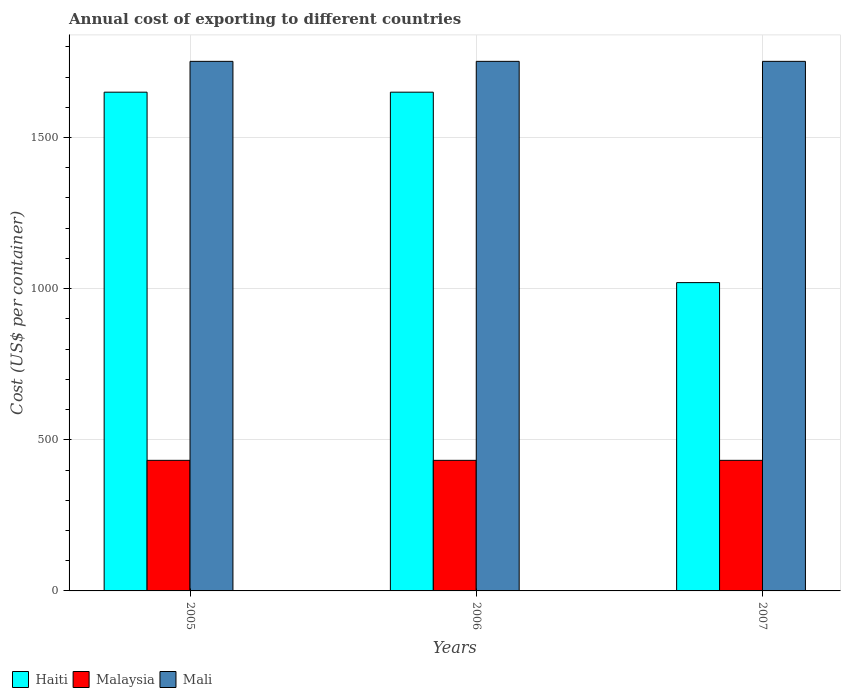Are the number of bars per tick equal to the number of legend labels?
Give a very brief answer. Yes. Are the number of bars on each tick of the X-axis equal?
Offer a very short reply. Yes. How many bars are there on the 1st tick from the left?
Make the answer very short. 3. In how many cases, is the number of bars for a given year not equal to the number of legend labels?
Make the answer very short. 0. What is the total annual cost of exporting in Mali in 2005?
Offer a terse response. 1752. Across all years, what is the maximum total annual cost of exporting in Haiti?
Offer a terse response. 1650. Across all years, what is the minimum total annual cost of exporting in Malaysia?
Provide a short and direct response. 432. What is the total total annual cost of exporting in Haiti in the graph?
Give a very brief answer. 4320. What is the difference between the total annual cost of exporting in Malaysia in 2005 and that in 2006?
Offer a terse response. 0. What is the difference between the total annual cost of exporting in Mali in 2005 and the total annual cost of exporting in Haiti in 2006?
Provide a short and direct response. 102. What is the average total annual cost of exporting in Mali per year?
Make the answer very short. 1752. In the year 2007, what is the difference between the total annual cost of exporting in Haiti and total annual cost of exporting in Malaysia?
Your answer should be very brief. 588. Is the total annual cost of exporting in Mali in 2005 less than that in 2007?
Offer a very short reply. No. What is the difference between the highest and the lowest total annual cost of exporting in Haiti?
Your response must be concise. 630. Is the sum of the total annual cost of exporting in Mali in 2005 and 2007 greater than the maximum total annual cost of exporting in Haiti across all years?
Give a very brief answer. Yes. What does the 2nd bar from the left in 2006 represents?
Offer a very short reply. Malaysia. What does the 1st bar from the right in 2006 represents?
Ensure brevity in your answer.  Mali. Are all the bars in the graph horizontal?
Keep it short and to the point. No. How many years are there in the graph?
Make the answer very short. 3. How many legend labels are there?
Give a very brief answer. 3. How are the legend labels stacked?
Give a very brief answer. Horizontal. What is the title of the graph?
Keep it short and to the point. Annual cost of exporting to different countries. What is the label or title of the Y-axis?
Offer a very short reply. Cost (US$ per container). What is the Cost (US$ per container) of Haiti in 2005?
Make the answer very short. 1650. What is the Cost (US$ per container) in Malaysia in 2005?
Provide a short and direct response. 432. What is the Cost (US$ per container) of Mali in 2005?
Offer a terse response. 1752. What is the Cost (US$ per container) of Haiti in 2006?
Your answer should be very brief. 1650. What is the Cost (US$ per container) in Malaysia in 2006?
Your answer should be compact. 432. What is the Cost (US$ per container) in Mali in 2006?
Your answer should be very brief. 1752. What is the Cost (US$ per container) in Haiti in 2007?
Make the answer very short. 1020. What is the Cost (US$ per container) in Malaysia in 2007?
Give a very brief answer. 432. What is the Cost (US$ per container) in Mali in 2007?
Your answer should be very brief. 1752. Across all years, what is the maximum Cost (US$ per container) of Haiti?
Give a very brief answer. 1650. Across all years, what is the maximum Cost (US$ per container) of Malaysia?
Your answer should be compact. 432. Across all years, what is the maximum Cost (US$ per container) in Mali?
Ensure brevity in your answer.  1752. Across all years, what is the minimum Cost (US$ per container) in Haiti?
Offer a terse response. 1020. Across all years, what is the minimum Cost (US$ per container) in Malaysia?
Your answer should be very brief. 432. Across all years, what is the minimum Cost (US$ per container) in Mali?
Give a very brief answer. 1752. What is the total Cost (US$ per container) in Haiti in the graph?
Keep it short and to the point. 4320. What is the total Cost (US$ per container) of Malaysia in the graph?
Keep it short and to the point. 1296. What is the total Cost (US$ per container) of Mali in the graph?
Give a very brief answer. 5256. What is the difference between the Cost (US$ per container) of Haiti in 2005 and that in 2006?
Ensure brevity in your answer.  0. What is the difference between the Cost (US$ per container) in Haiti in 2005 and that in 2007?
Give a very brief answer. 630. What is the difference between the Cost (US$ per container) in Malaysia in 2005 and that in 2007?
Your response must be concise. 0. What is the difference between the Cost (US$ per container) in Haiti in 2006 and that in 2007?
Make the answer very short. 630. What is the difference between the Cost (US$ per container) of Malaysia in 2006 and that in 2007?
Give a very brief answer. 0. What is the difference between the Cost (US$ per container) of Haiti in 2005 and the Cost (US$ per container) of Malaysia in 2006?
Your answer should be very brief. 1218. What is the difference between the Cost (US$ per container) in Haiti in 2005 and the Cost (US$ per container) in Mali in 2006?
Offer a terse response. -102. What is the difference between the Cost (US$ per container) of Malaysia in 2005 and the Cost (US$ per container) of Mali in 2006?
Offer a very short reply. -1320. What is the difference between the Cost (US$ per container) in Haiti in 2005 and the Cost (US$ per container) in Malaysia in 2007?
Your answer should be compact. 1218. What is the difference between the Cost (US$ per container) of Haiti in 2005 and the Cost (US$ per container) of Mali in 2007?
Ensure brevity in your answer.  -102. What is the difference between the Cost (US$ per container) in Malaysia in 2005 and the Cost (US$ per container) in Mali in 2007?
Ensure brevity in your answer.  -1320. What is the difference between the Cost (US$ per container) of Haiti in 2006 and the Cost (US$ per container) of Malaysia in 2007?
Provide a succinct answer. 1218. What is the difference between the Cost (US$ per container) of Haiti in 2006 and the Cost (US$ per container) of Mali in 2007?
Keep it short and to the point. -102. What is the difference between the Cost (US$ per container) in Malaysia in 2006 and the Cost (US$ per container) in Mali in 2007?
Your answer should be very brief. -1320. What is the average Cost (US$ per container) in Haiti per year?
Ensure brevity in your answer.  1440. What is the average Cost (US$ per container) in Malaysia per year?
Your answer should be very brief. 432. What is the average Cost (US$ per container) of Mali per year?
Provide a succinct answer. 1752. In the year 2005, what is the difference between the Cost (US$ per container) of Haiti and Cost (US$ per container) of Malaysia?
Provide a succinct answer. 1218. In the year 2005, what is the difference between the Cost (US$ per container) of Haiti and Cost (US$ per container) of Mali?
Ensure brevity in your answer.  -102. In the year 2005, what is the difference between the Cost (US$ per container) in Malaysia and Cost (US$ per container) in Mali?
Keep it short and to the point. -1320. In the year 2006, what is the difference between the Cost (US$ per container) of Haiti and Cost (US$ per container) of Malaysia?
Your response must be concise. 1218. In the year 2006, what is the difference between the Cost (US$ per container) of Haiti and Cost (US$ per container) of Mali?
Offer a very short reply. -102. In the year 2006, what is the difference between the Cost (US$ per container) of Malaysia and Cost (US$ per container) of Mali?
Offer a very short reply. -1320. In the year 2007, what is the difference between the Cost (US$ per container) in Haiti and Cost (US$ per container) in Malaysia?
Ensure brevity in your answer.  588. In the year 2007, what is the difference between the Cost (US$ per container) of Haiti and Cost (US$ per container) of Mali?
Offer a terse response. -732. In the year 2007, what is the difference between the Cost (US$ per container) of Malaysia and Cost (US$ per container) of Mali?
Offer a terse response. -1320. What is the ratio of the Cost (US$ per container) in Mali in 2005 to that in 2006?
Keep it short and to the point. 1. What is the ratio of the Cost (US$ per container) of Haiti in 2005 to that in 2007?
Offer a terse response. 1.62. What is the ratio of the Cost (US$ per container) of Malaysia in 2005 to that in 2007?
Make the answer very short. 1. What is the ratio of the Cost (US$ per container) in Haiti in 2006 to that in 2007?
Offer a terse response. 1.62. What is the difference between the highest and the second highest Cost (US$ per container) in Haiti?
Your answer should be very brief. 0. What is the difference between the highest and the lowest Cost (US$ per container) in Haiti?
Your answer should be very brief. 630. 